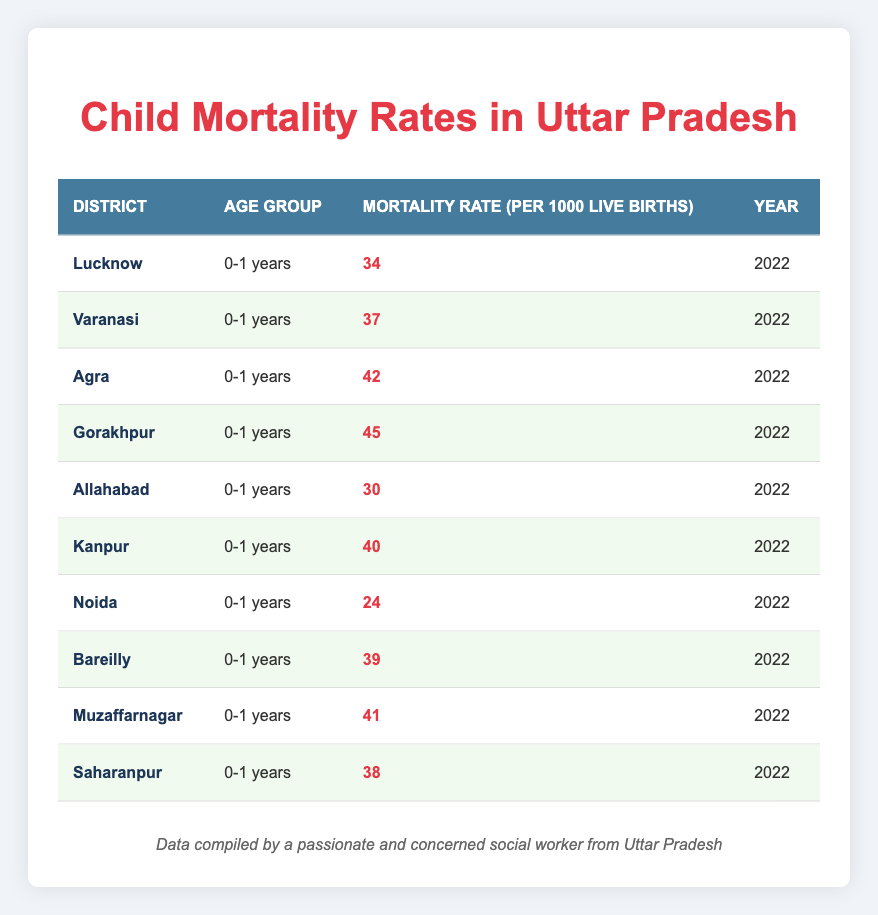What is the mortality rate in Noida? By looking at the table, I can find the row for Noida and see the "Mortality Rate (per 1000 Live Births)" which is listed as 24.
Answer: 24 Which district has the highest mortality rate for children under one year? By scanning the table to identify the maximum value in the "Mortality Rate (per 1000 Live Births)" column, I see that Gorakhpur has the highest rate at 45.
Answer: 45 What is the average mortality rate across all the listed districts? To find the average, I first sum the mortality rates: 34 + 37 + 42 + 45 + 30 + 40 + 24 + 39 + 41 + 38 =  420. Since there are 10 districts, I divide the total by 10: 420 / 10 = 42.
Answer: 42 Is the mortality rate in Varanasi higher than that in Allahabad? I can compare the specific mortality rates listed for Varanasi (37) and Allahabad (30) in the table. Since 37 is greater than 30, the statement is true.
Answer: Yes Which district has a mortality rate closest to the average? The average mortality rate calculated is 42. Looking at each district's rate, Agra (42) is exactly equal to the average, while the closest others are Lucknow (34), and Kanpur (40).
Answer: Agra What is the difference in mortality rates between Gorakhpur and Noida? From the table, Gorakhpur has a mortality rate of 45 and Noida has a rate of 24. To find the difference, I subtract Noida's rate from Gorakhpur's: 45 - 24 = 21.
Answer: 21 How many districts have a mortality rate greater than 40? By reviewing the table, I see that Agra (42), Gorakhpur (45), Muzaffarnagar (41) and Kanpur (40) have rates greater than 40. This gives us a total of 4 districts.
Answer: 4 Is it true that all districts have a mortality rate below 50? A quick overview of the table shows the highest mortality rate is 45 in Gorakhpur. Therefore, every district listed has a mortality rate below 50, confirming the statement is true.
Answer: Yes Which district has the lowest mortality rate and what is that rate? Looking through the table, I find that Noida has the lowest mortality rate, which is 24.
Answer: 24 